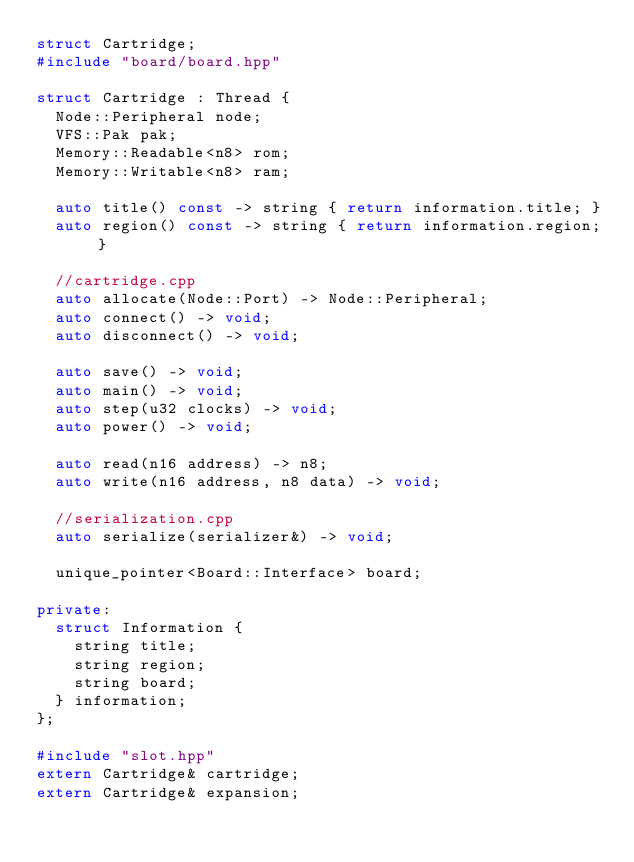<code> <loc_0><loc_0><loc_500><loc_500><_C++_>struct Cartridge;
#include "board/board.hpp"

struct Cartridge : Thread {
  Node::Peripheral node;
  VFS::Pak pak;
  Memory::Readable<n8> rom;
  Memory::Writable<n8> ram;

  auto title() const -> string { return information.title; }
  auto region() const -> string { return information.region; }

  //cartridge.cpp
  auto allocate(Node::Port) -> Node::Peripheral;
  auto connect() -> void;
  auto disconnect() -> void;

  auto save() -> void;
  auto main() -> void;
  auto step(u32 clocks) -> void;
  auto power() -> void;

  auto read(n16 address) -> n8;
  auto write(n16 address, n8 data) -> void;

  //serialization.cpp
  auto serialize(serializer&) -> void;

  unique_pointer<Board::Interface> board;

private:
  struct Information {
    string title;
    string region;
    string board;
  } information;
};

#include "slot.hpp"
extern Cartridge& cartridge;
extern Cartridge& expansion;
</code> 